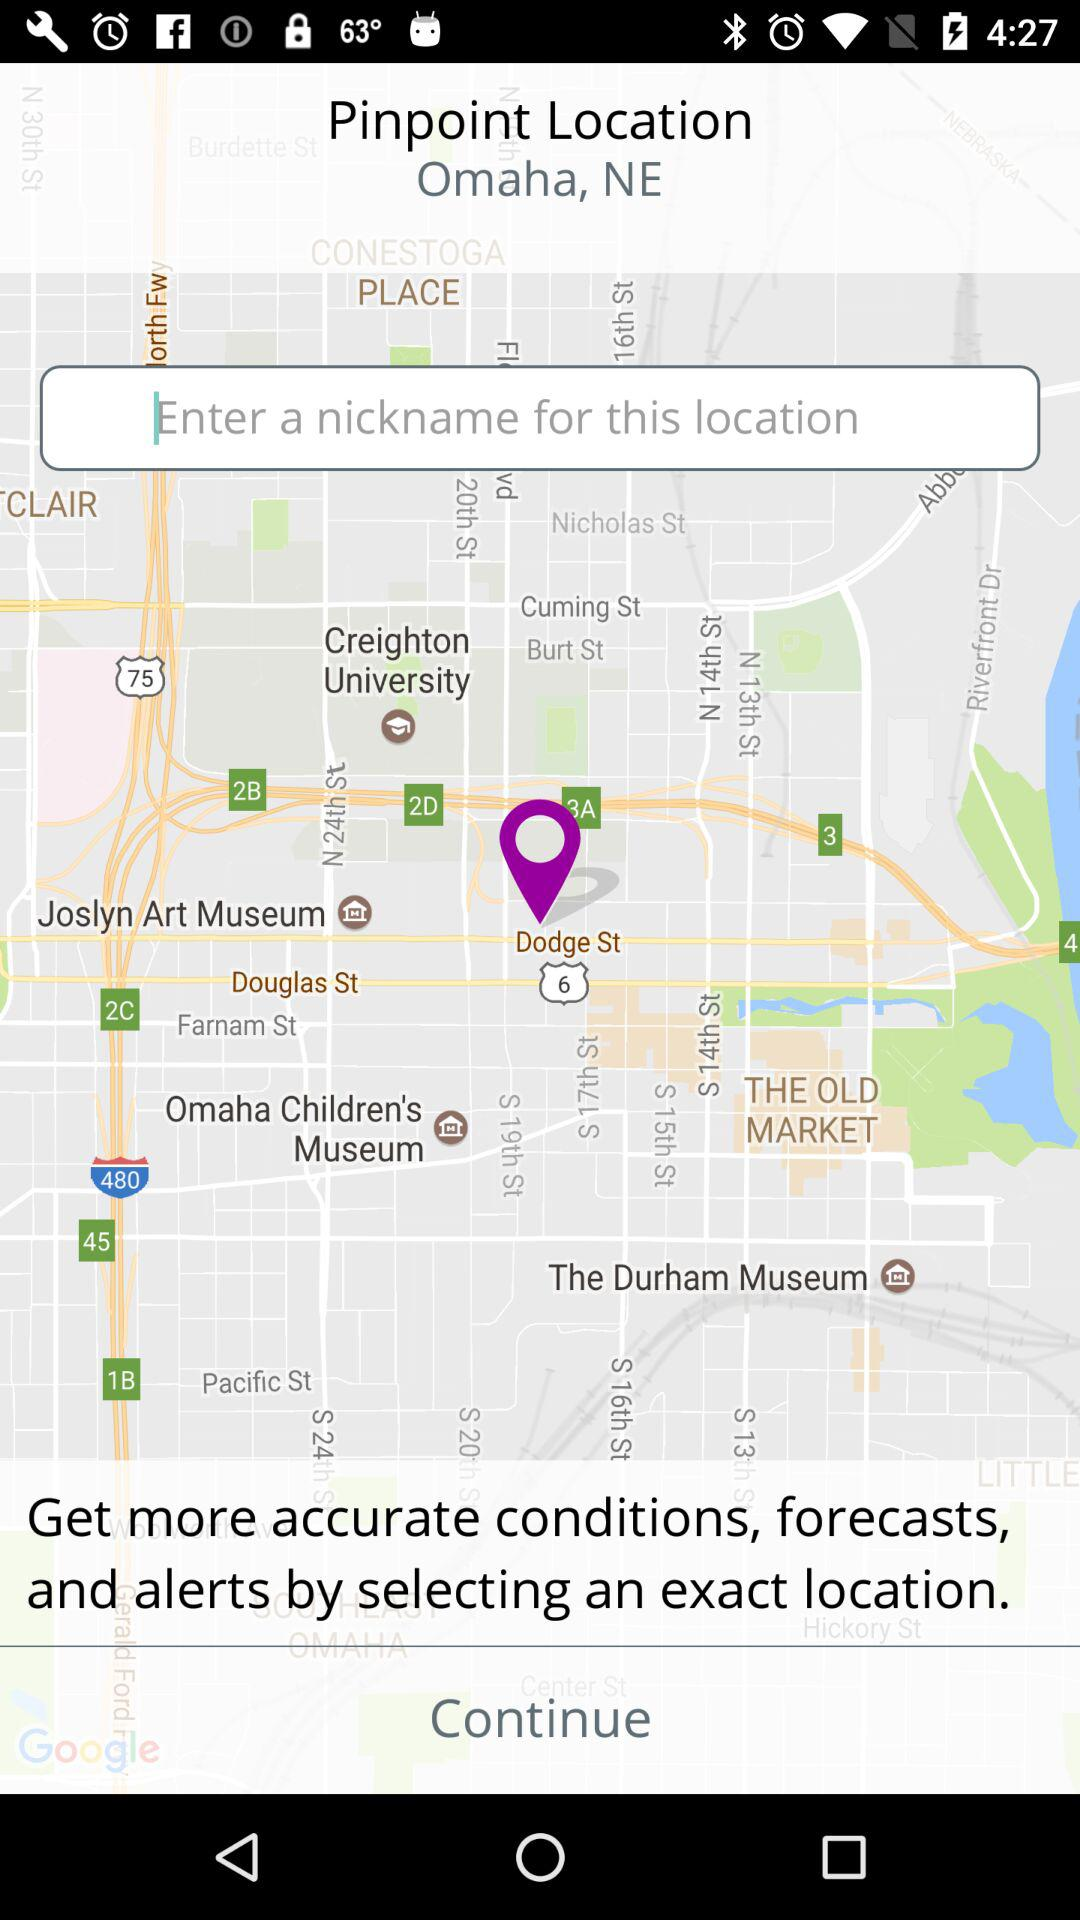What is the pinpoint location? The pinpoint location is Omaha, NE. 